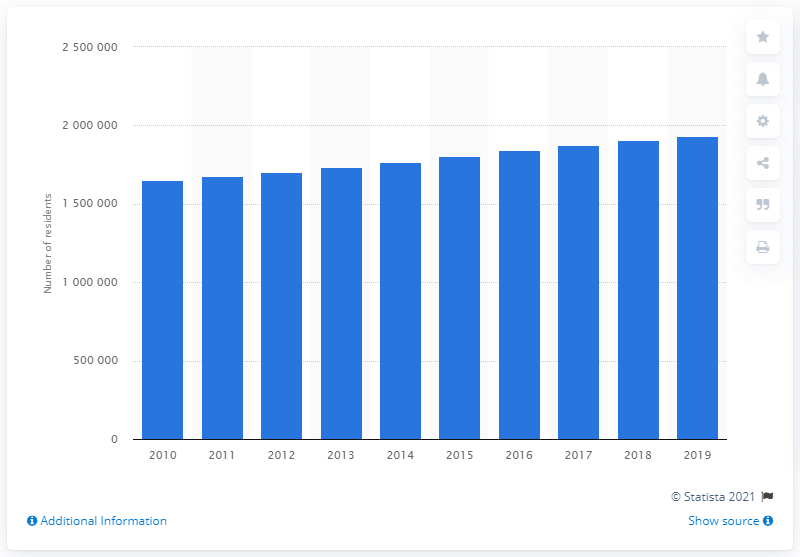Mention a couple of crucial points in this snapshot. In 2019, the Nashville-Davidson-Murfreesboro-Franklin metropolitan area had a population of 1,934,317 people. 